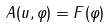Convert formula to latex. <formula><loc_0><loc_0><loc_500><loc_500>A ( u , \varphi ) = F ( \varphi )</formula> 